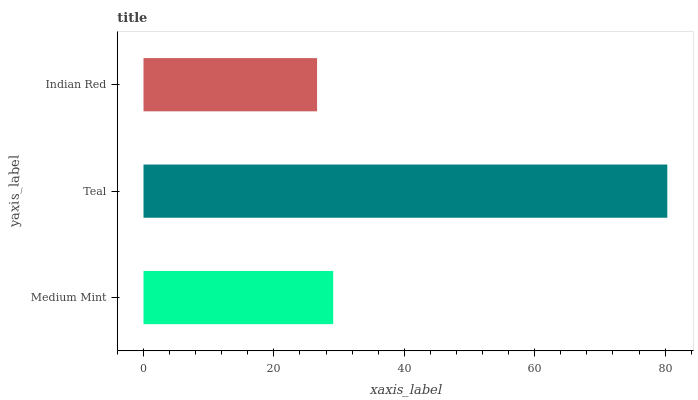Is Indian Red the minimum?
Answer yes or no. Yes. Is Teal the maximum?
Answer yes or no. Yes. Is Teal the minimum?
Answer yes or no. No. Is Indian Red the maximum?
Answer yes or no. No. Is Teal greater than Indian Red?
Answer yes or no. Yes. Is Indian Red less than Teal?
Answer yes or no. Yes. Is Indian Red greater than Teal?
Answer yes or no. No. Is Teal less than Indian Red?
Answer yes or no. No. Is Medium Mint the high median?
Answer yes or no. Yes. Is Medium Mint the low median?
Answer yes or no. Yes. Is Indian Red the high median?
Answer yes or no. No. Is Teal the low median?
Answer yes or no. No. 